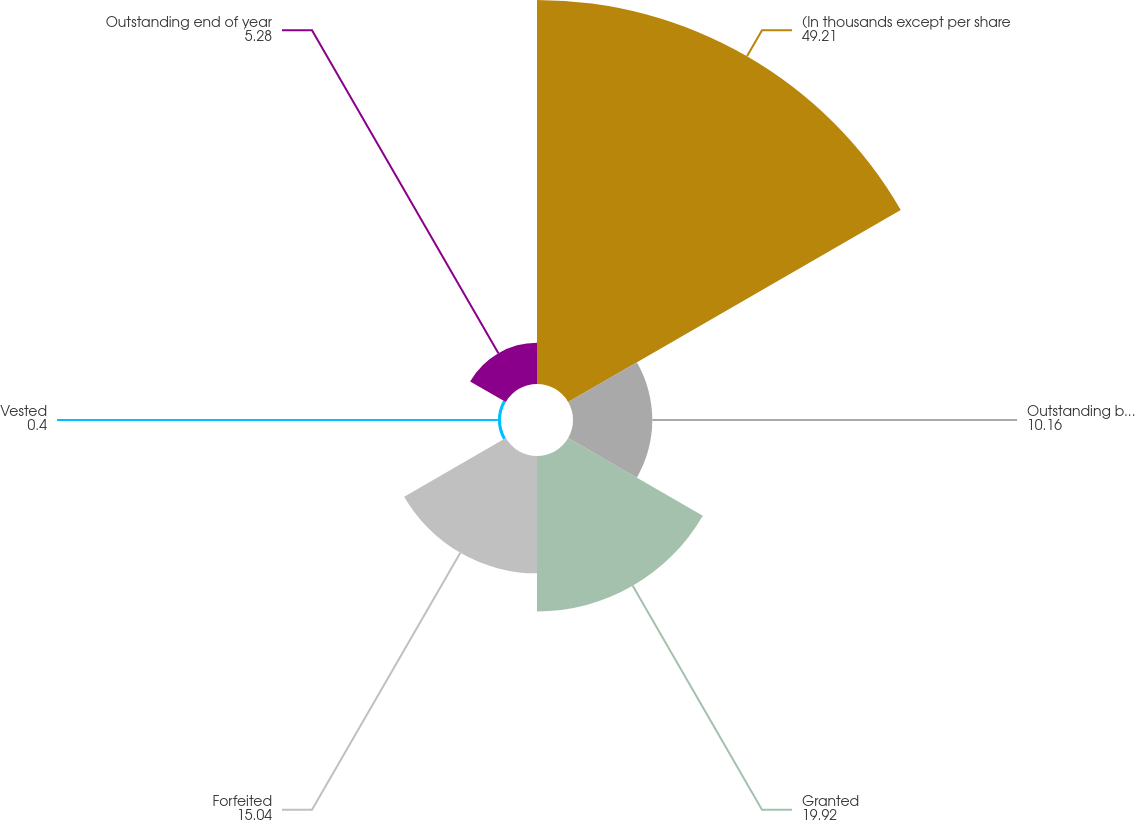<chart> <loc_0><loc_0><loc_500><loc_500><pie_chart><fcel>(In thousands except per share<fcel>Outstanding beginning of year<fcel>Granted<fcel>Forfeited<fcel>Vested<fcel>Outstanding end of year<nl><fcel>49.21%<fcel>10.16%<fcel>19.92%<fcel>15.04%<fcel>0.4%<fcel>5.28%<nl></chart> 